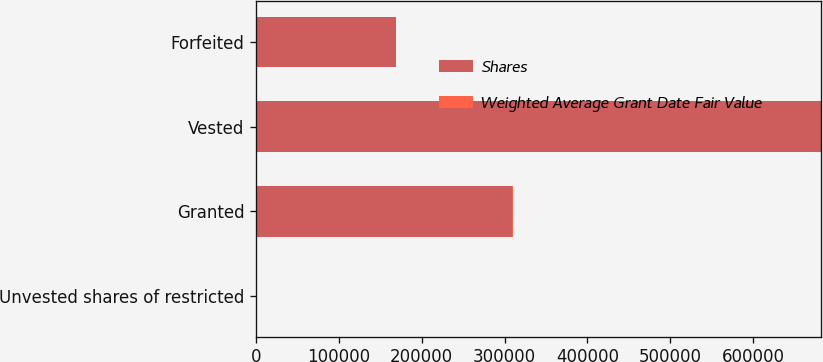Convert chart. <chart><loc_0><loc_0><loc_500><loc_500><stacked_bar_chart><ecel><fcel>Unvested shares of restricted<fcel>Granted<fcel>Vested<fcel>Forfeited<nl><fcel>Shares<fcel>60<fcel>309526<fcel>681699<fcel>168661<nl><fcel>Weighted Average Grant Date Fair Value<fcel>20.56<fcel>60<fcel>6.67<fcel>35.2<nl></chart> 